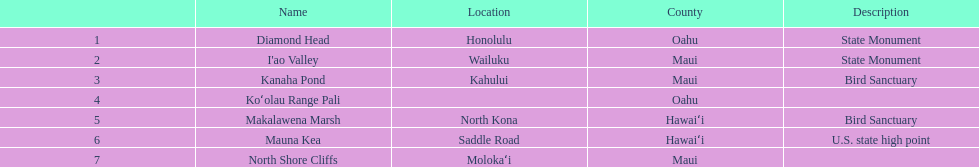What's the complete number of landmarks present in maui? 3. 